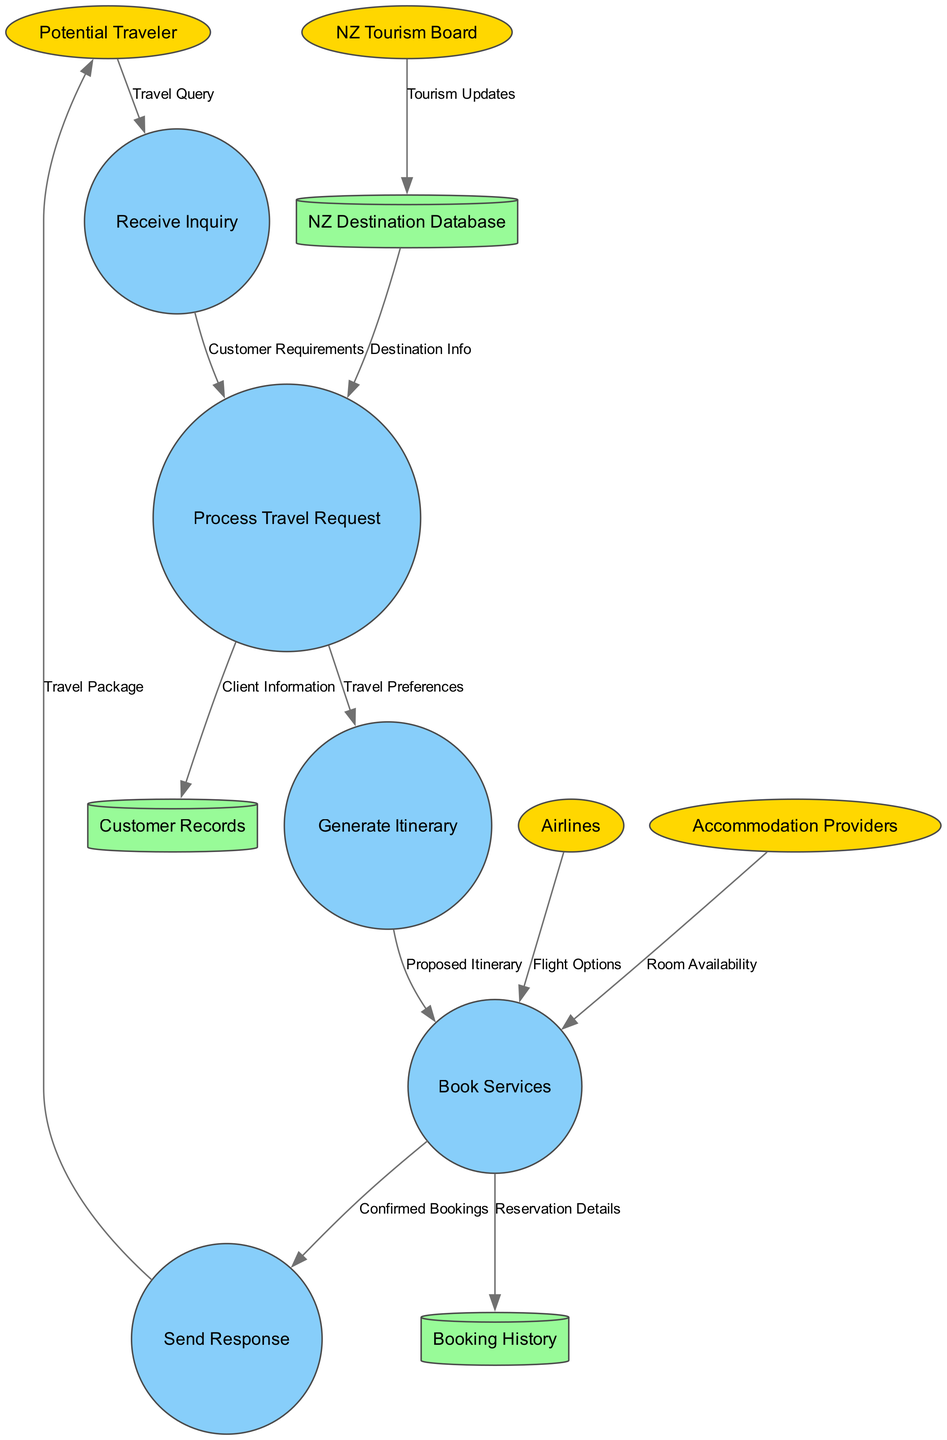What are the external entities in this diagram? The external entities can be identified as those nodes represented by ellipses. In the diagram, they are: Potential Traveler, NZ Tourism Board, Airlines, and Accommodation Providers.
Answer: Potential Traveler, NZ Tourism Board, Airlines, Accommodation Providers How many processes are depicted in the diagram? The processes are represented by circular nodes. By counting these nodes in the diagram, we see there are five processes: Receive Inquiry, Process Travel Request, Generate Itinerary, Book Services, and Send Response.
Answer: Five What type of information is sent from the Potential Traveler to the Receive Inquiry process? The information is labeled as "Travel Query," which indicates it is the query or inquiry about travel that the Potential Traveler initiates to kick off the process.
Answer: Travel Query Which data store receives client information during the Process Travel Request? According to the data flow, during the Process Travel Request, information identified as "Client Information" is directed to a specific node, which is the Customer Records data store.
Answer: Customer Records What is the final output sent to the Potential Traveler after booking services? The last node in the data flow indicates that the output is labeled "Travel Package," which is the confirmation or package details sent back to the Potential Traveler.
Answer: Travel Package How many data flows are there in the diagram? Each directed edge in the diagram represents a data flow, which connects entities, processes, or data stores. By counting these edges, we identify that there are a total of eleven data flows.
Answer: Eleven What flow occurs between the NZ Tourism Board and the NZ Destination Database? The flow between these two nodes is labeled as "Tourism Updates," indicating that the NZ Tourism Board provides updates to the NZ Destination Database for maintaining current information.
Answer: Tourism Updates Which two entities provide inputs to the Book Services process? By examining the diagram, we can see that both Airlines and Accommodation Providers send specific inputs labeled as "Flight Options" and "Room Availability," respectively, to the Book Services process.
Answer: Airlines, Accommodation Providers What are the types of services booked as indicated in the Book Services process? The services are determined through the bookings made based on the Proposed Itinerary which is generated earlier in the data flow, and includes all confirmed reservations. Hence, the answer encompasses the confirmed bookings from various providers.
Answer: Confirmed Bookings 